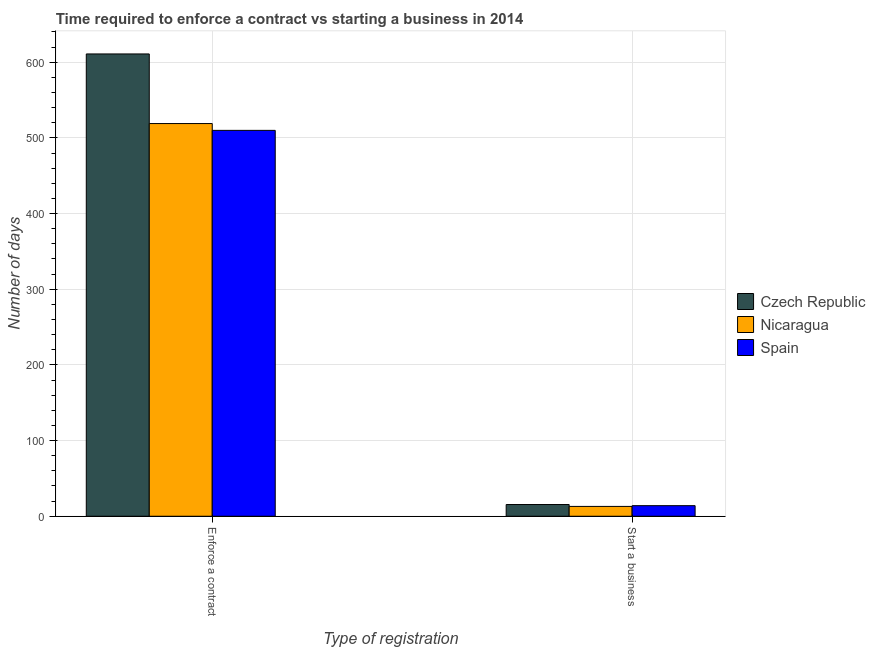How many groups of bars are there?
Give a very brief answer. 2. Are the number of bars on each tick of the X-axis equal?
Offer a very short reply. Yes. How many bars are there on the 2nd tick from the left?
Ensure brevity in your answer.  3. How many bars are there on the 2nd tick from the right?
Give a very brief answer. 3. What is the label of the 1st group of bars from the left?
Keep it short and to the point. Enforce a contract. What is the number of days to start a business in Nicaragua?
Ensure brevity in your answer.  13. Across all countries, what is the minimum number of days to enforece a contract?
Offer a terse response. 510. In which country was the number of days to start a business maximum?
Your answer should be compact. Czech Republic. In which country was the number of days to start a business minimum?
Your response must be concise. Nicaragua. What is the total number of days to start a business in the graph?
Your answer should be very brief. 42.5. What is the difference between the number of days to enforece a contract in Czech Republic and the number of days to start a business in Nicaragua?
Provide a succinct answer. 598. What is the average number of days to start a business per country?
Make the answer very short. 14.17. What is the difference between the number of days to enforece a contract and number of days to start a business in Nicaragua?
Offer a terse response. 506. In how many countries, is the number of days to enforece a contract greater than 260 days?
Provide a short and direct response. 3. What is the ratio of the number of days to enforece a contract in Nicaragua to that in Spain?
Give a very brief answer. 1.02. Is the number of days to enforece a contract in Czech Republic less than that in Nicaragua?
Your answer should be compact. No. In how many countries, is the number of days to enforece a contract greater than the average number of days to enforece a contract taken over all countries?
Ensure brevity in your answer.  1. What does the 1st bar from the left in Start a business represents?
Provide a short and direct response. Czech Republic. What does the 3rd bar from the right in Enforce a contract represents?
Give a very brief answer. Czech Republic. How many bars are there?
Provide a short and direct response. 6. How many countries are there in the graph?
Offer a terse response. 3. Does the graph contain any zero values?
Offer a very short reply. No. Does the graph contain grids?
Make the answer very short. Yes. How many legend labels are there?
Your response must be concise. 3. What is the title of the graph?
Your answer should be compact. Time required to enforce a contract vs starting a business in 2014. What is the label or title of the X-axis?
Give a very brief answer. Type of registration. What is the label or title of the Y-axis?
Ensure brevity in your answer.  Number of days. What is the Number of days in Czech Republic in Enforce a contract?
Provide a short and direct response. 611. What is the Number of days of Nicaragua in Enforce a contract?
Ensure brevity in your answer.  519. What is the Number of days in Spain in Enforce a contract?
Keep it short and to the point. 510. What is the Number of days of Czech Republic in Start a business?
Offer a very short reply. 15.5. What is the Number of days in Nicaragua in Start a business?
Keep it short and to the point. 13. What is the Number of days in Spain in Start a business?
Provide a short and direct response. 14. Across all Type of registration, what is the maximum Number of days in Czech Republic?
Give a very brief answer. 611. Across all Type of registration, what is the maximum Number of days in Nicaragua?
Make the answer very short. 519. Across all Type of registration, what is the maximum Number of days of Spain?
Offer a terse response. 510. Across all Type of registration, what is the minimum Number of days in Czech Republic?
Give a very brief answer. 15.5. What is the total Number of days in Czech Republic in the graph?
Keep it short and to the point. 626.5. What is the total Number of days in Nicaragua in the graph?
Offer a very short reply. 532. What is the total Number of days of Spain in the graph?
Offer a very short reply. 524. What is the difference between the Number of days in Czech Republic in Enforce a contract and that in Start a business?
Provide a succinct answer. 595.5. What is the difference between the Number of days of Nicaragua in Enforce a contract and that in Start a business?
Offer a very short reply. 506. What is the difference between the Number of days of Spain in Enforce a contract and that in Start a business?
Keep it short and to the point. 496. What is the difference between the Number of days in Czech Republic in Enforce a contract and the Number of days in Nicaragua in Start a business?
Keep it short and to the point. 598. What is the difference between the Number of days of Czech Republic in Enforce a contract and the Number of days of Spain in Start a business?
Make the answer very short. 597. What is the difference between the Number of days of Nicaragua in Enforce a contract and the Number of days of Spain in Start a business?
Provide a succinct answer. 505. What is the average Number of days in Czech Republic per Type of registration?
Keep it short and to the point. 313.25. What is the average Number of days in Nicaragua per Type of registration?
Provide a short and direct response. 266. What is the average Number of days of Spain per Type of registration?
Provide a short and direct response. 262. What is the difference between the Number of days in Czech Republic and Number of days in Nicaragua in Enforce a contract?
Provide a short and direct response. 92. What is the difference between the Number of days in Czech Republic and Number of days in Spain in Enforce a contract?
Your response must be concise. 101. What is the difference between the Number of days of Nicaragua and Number of days of Spain in Enforce a contract?
Offer a terse response. 9. What is the difference between the Number of days of Nicaragua and Number of days of Spain in Start a business?
Make the answer very short. -1. What is the ratio of the Number of days of Czech Republic in Enforce a contract to that in Start a business?
Offer a very short reply. 39.42. What is the ratio of the Number of days in Nicaragua in Enforce a contract to that in Start a business?
Your answer should be compact. 39.92. What is the ratio of the Number of days in Spain in Enforce a contract to that in Start a business?
Your response must be concise. 36.43. What is the difference between the highest and the second highest Number of days of Czech Republic?
Ensure brevity in your answer.  595.5. What is the difference between the highest and the second highest Number of days in Nicaragua?
Provide a short and direct response. 506. What is the difference between the highest and the second highest Number of days of Spain?
Ensure brevity in your answer.  496. What is the difference between the highest and the lowest Number of days in Czech Republic?
Provide a short and direct response. 595.5. What is the difference between the highest and the lowest Number of days of Nicaragua?
Offer a very short reply. 506. What is the difference between the highest and the lowest Number of days of Spain?
Give a very brief answer. 496. 